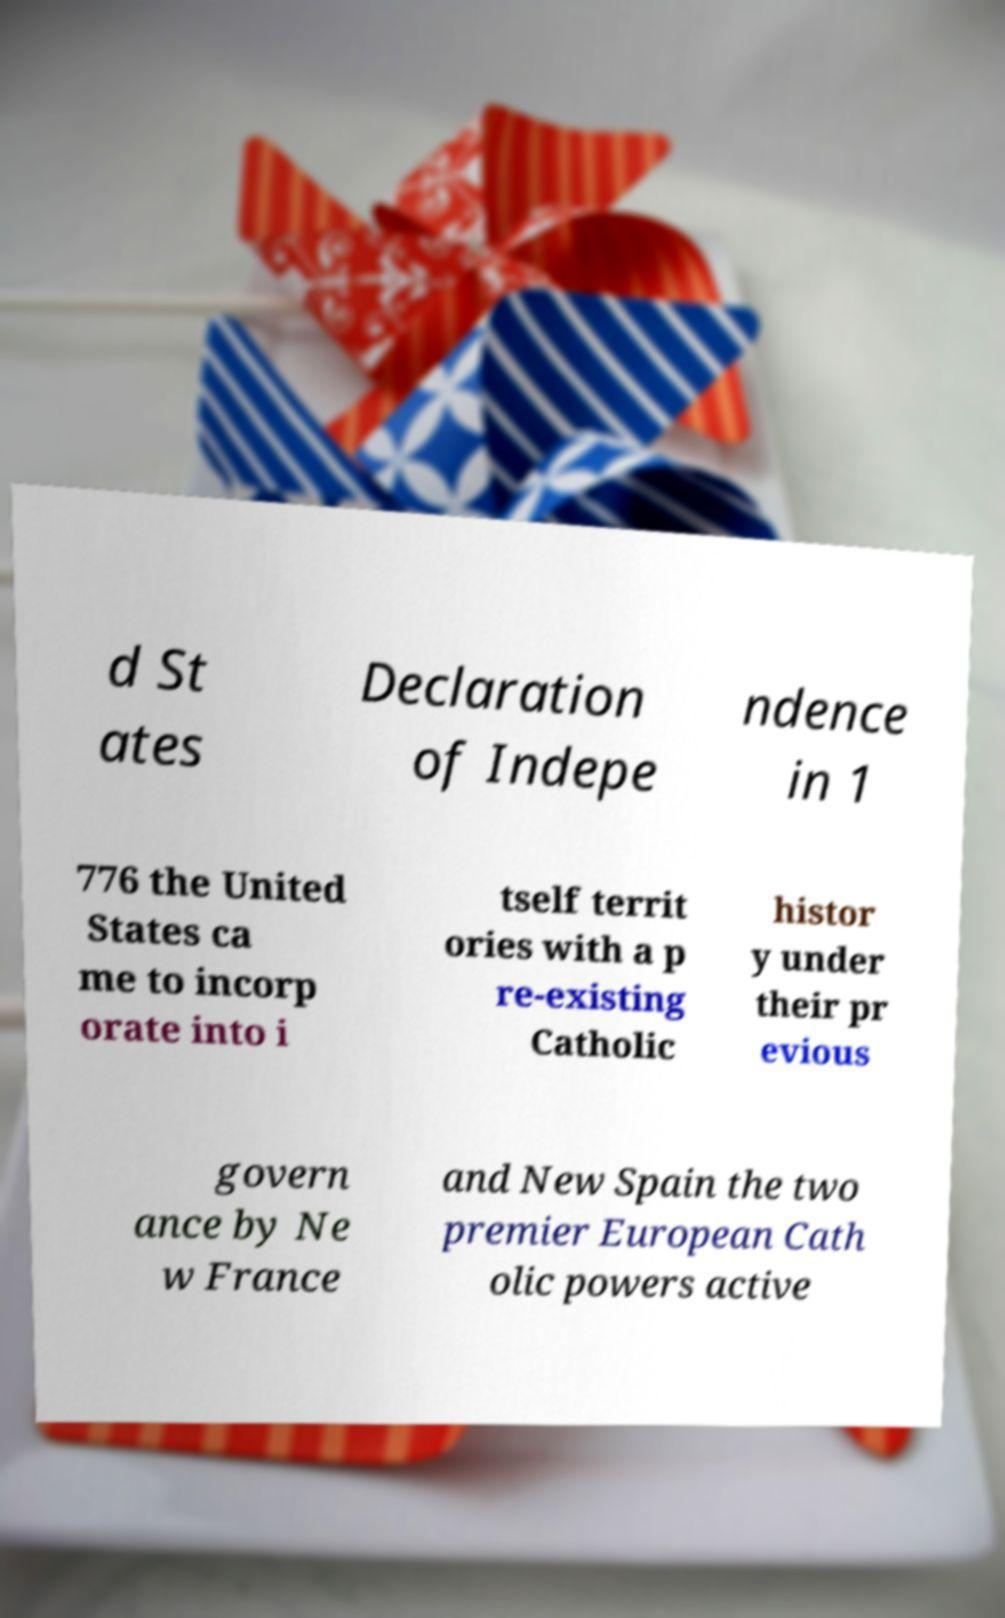Can you accurately transcribe the text from the provided image for me? d St ates Declaration of Indepe ndence in 1 776 the United States ca me to incorp orate into i tself territ ories with a p re-existing Catholic histor y under their pr evious govern ance by Ne w France and New Spain the two premier European Cath olic powers active 